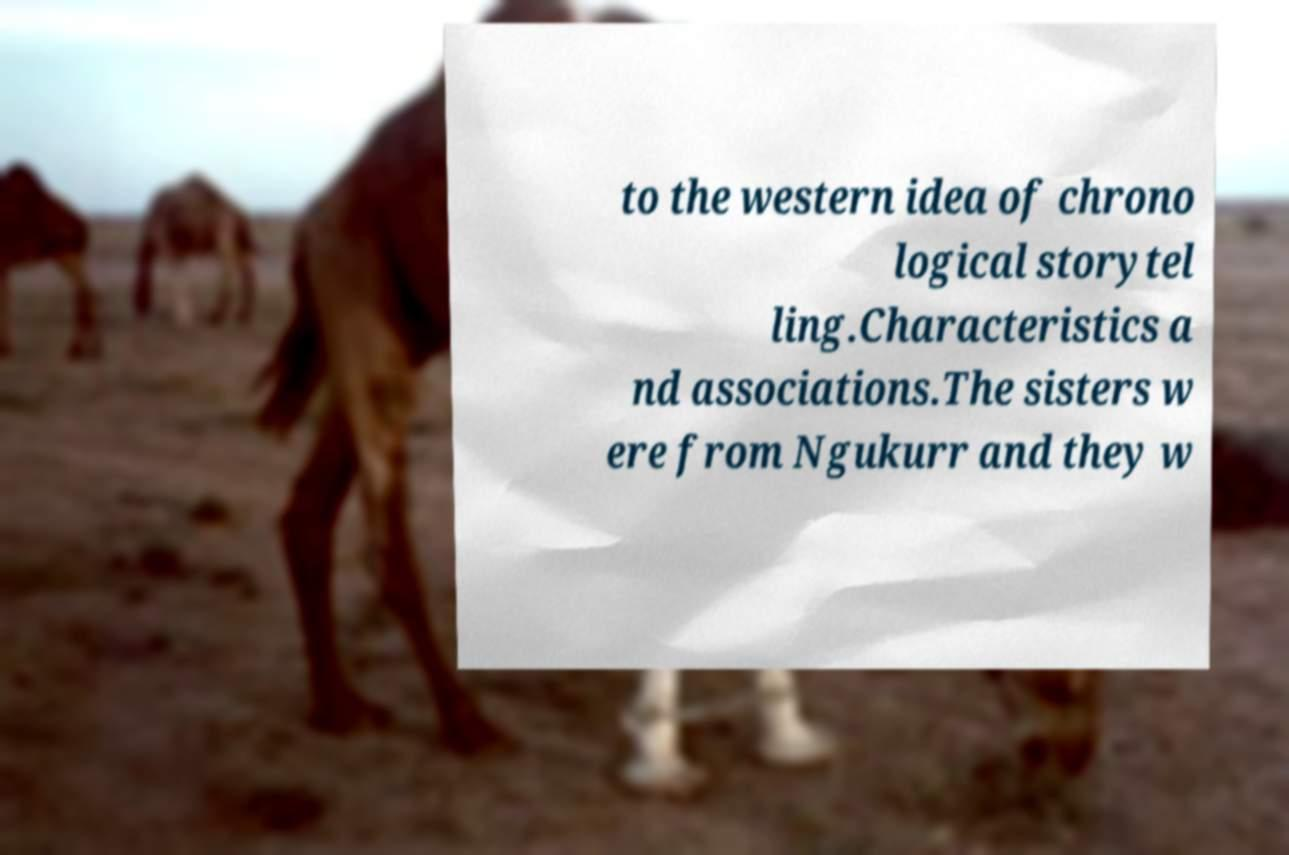I need the written content from this picture converted into text. Can you do that? to the western idea of chrono logical storytel ling.Characteristics a nd associations.The sisters w ere from Ngukurr and they w 